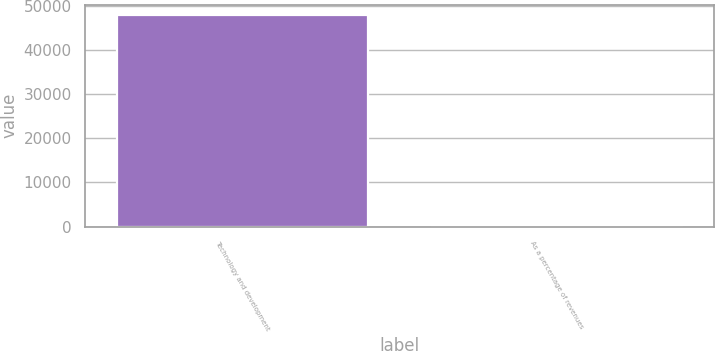Convert chart. <chart><loc_0><loc_0><loc_500><loc_500><bar_chart><fcel>Technology and development<fcel>As a percentage of revenues<nl><fcel>47831<fcel>4.8<nl></chart> 